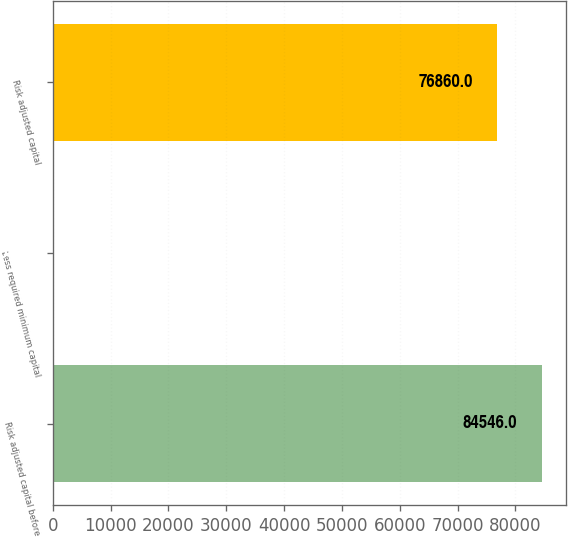Convert chart to OTSL. <chart><loc_0><loc_0><loc_500><loc_500><bar_chart><fcel>Risk adjusted capital before<fcel>Less required minimum capital<fcel>Risk adjusted capital<nl><fcel>84546<fcel>250<fcel>76860<nl></chart> 